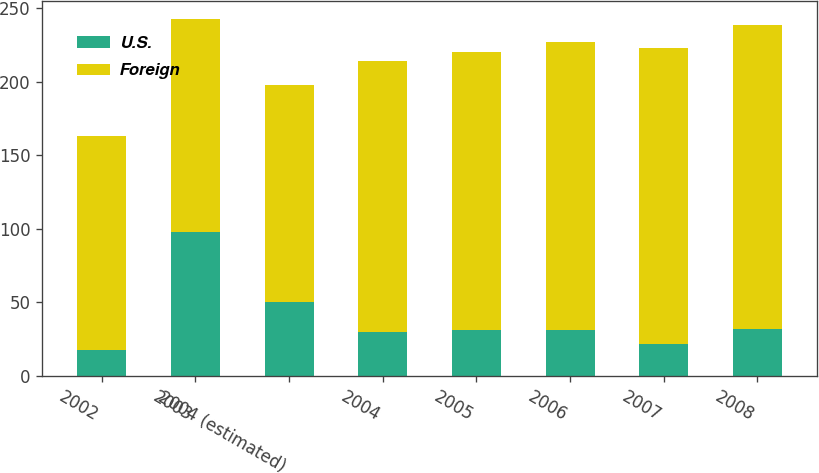<chart> <loc_0><loc_0><loc_500><loc_500><stacked_bar_chart><ecel><fcel>2002<fcel>2003<fcel>2004 (estimated)<fcel>2004<fcel>2005<fcel>2006<fcel>2007<fcel>2008<nl><fcel>U.S.<fcel>18<fcel>98<fcel>50<fcel>30<fcel>31<fcel>31<fcel>22<fcel>32<nl><fcel>Foreign<fcel>145<fcel>145<fcel>148<fcel>184<fcel>189<fcel>196<fcel>201<fcel>207<nl></chart> 